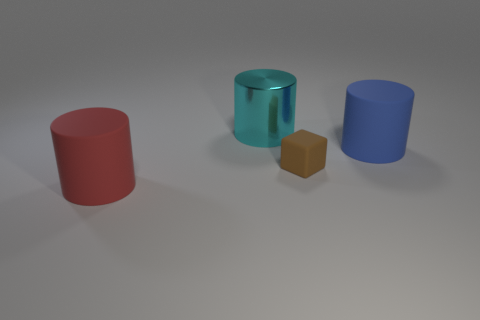Subtract all rubber cylinders. How many cylinders are left? 1 Add 4 big cyan things. How many objects exist? 8 Subtract 1 cylinders. How many cylinders are left? 2 Subtract all cylinders. How many objects are left? 1 Add 3 large yellow cylinders. How many large yellow cylinders exist? 3 Subtract 0 green cubes. How many objects are left? 4 Subtract all red cylinders. Subtract all blue balls. How many cylinders are left? 2 Subtract all tiny brown matte objects. Subtract all big cubes. How many objects are left? 3 Add 4 big blue objects. How many big blue objects are left? 5 